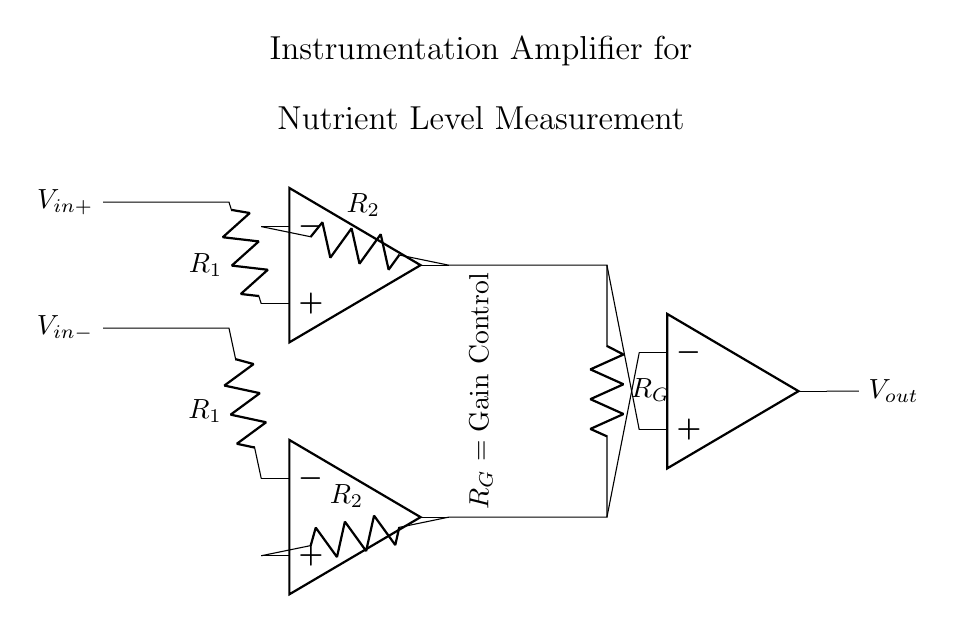What is the purpose of the resistor labeled R1? R1 is part of the input stage of the instrumentation amplifier, determining the input impedance and matched gain for the differential signals.
Answer: Input impedance What does R_G control in this circuit? R_G is the gain resistor that sets the amplification level of the input signals before they are outputted, affecting the output voltage corresponding to the input voltage difference.
Answer: Gain How many operational amplifiers are used in this instrumentation amplifier? The diagram indicates three operational amplifiers, which are critical for achieving high precision in differential signal amplification.
Answer: Three What are the input voltage connections labeled as? The input voltage connections are labeled V_in+ and V_in-, indicating the positive and negative differential inputs to the instrumentation amplifier.
Answer: V_in+ and V_in- What happens to V_out if the input voltage difference increases? If the input voltage difference increases, V_out will also increase proportionally based on the gain set by R_G, a key characteristic of the amplifier's behavior.
Answer: V_out increases What type of measurements is this amplifier designed for? This instrumentation amplifier is designed for precise measurements, specifically tailored for detecting nutrient levels in blood samples, reflecting its medical application.
Answer: Nutrient level measurement Why is a differential amplifier configuration used here? The differential amplifier configuration is used to reject common-mode noise and enhance the accuracy of the measurement by focusing solely on the difference between the input signals.
Answer: To reject common-mode noise 